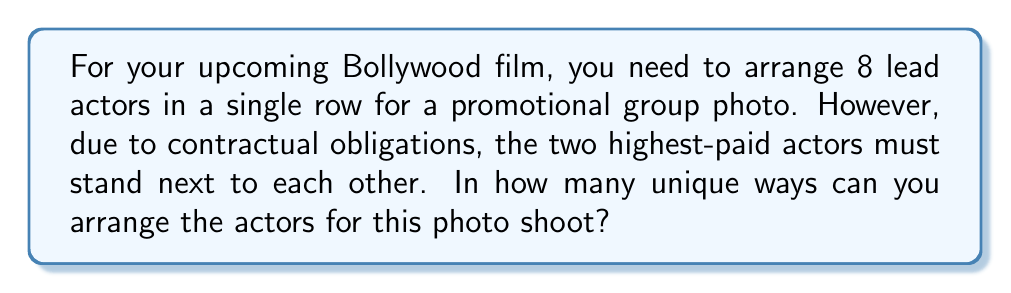Teach me how to tackle this problem. Let's approach this step-by-step:

1) First, consider the two highest-paid actors as a single unit. This means we now have 7 units to arrange (the pair of highest-paid actors plus the other 6 individual actors).

2) The number of ways to arrange 7 units in a row is a straightforward permutation:
   
   $P(7,7) = 7! = 7 \times 6 \times 5 \times 4 \times 3 \times 2 \times 1 = 5040$

3) However, we're not done yet. For each of these 5040 arrangements, the two highest-paid actors can swap positions with each other. This doubles our total number of arrangements.

4) Therefore, we multiply our result by 2:
   
   $5040 \times 2 = 10080$

So, the total number of unique arrangements is 10080.

This problem combines the concepts of permutations with a twist of considering certain elements as a unit, which is a common scenario in film production where certain actors might have special requirements or considerations.
Answer: $10080$ unique arrangements 